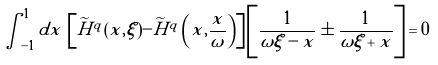<formula> <loc_0><loc_0><loc_500><loc_500>\int _ { - 1 } ^ { 1 } d x \, \left [ \widetilde { H } ^ { q } ( x , \xi ) - \widetilde { H } ^ { q } \left ( x , \frac { x } { \omega } \right ) \right ] \left [ \frac { 1 } { \omega \xi - x } \pm \frac { 1 } { \omega \xi + x } \right ] = 0</formula> 